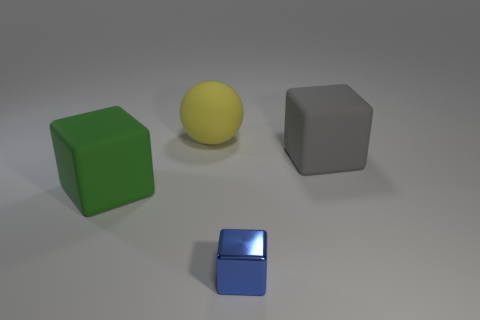What objects are present in the image, and what can you tell me about their colors and shapes? The image features four objects: a large green cube with a matte surface, a yellow sphere with a smooth texture, a smaller grey cube, and a tiny, reflective blue cube. The colors are quite distinct, and the shapes encompass the basic geometric forms of a cube and a sphere. 